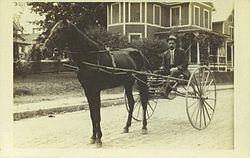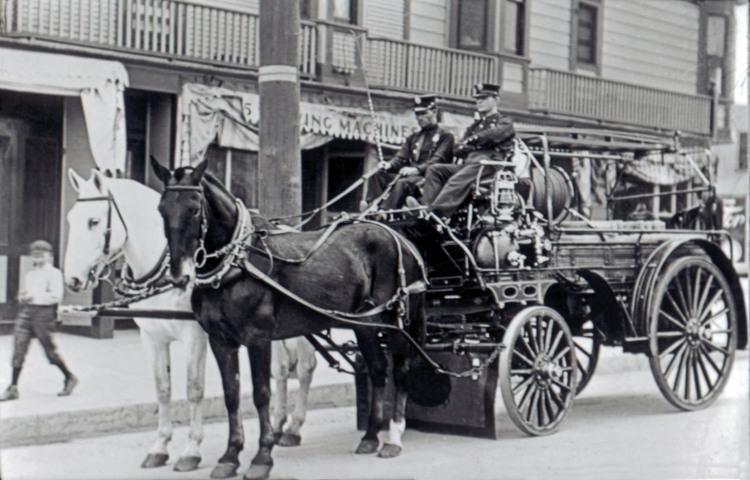The first image is the image on the left, the second image is the image on the right. Analyze the images presented: Is the assertion "In one of the images there is  a carriage with two horses hitched to it." valid? Answer yes or no. Yes. 